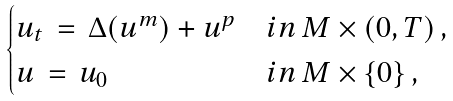Convert formula to latex. <formula><loc_0><loc_0><loc_500><loc_500>\begin{cases} u _ { t } \, = \, \Delta ( u ^ { m } ) + u ^ { p } & i n \, M \times ( 0 , T ) \, , \\ u \, = \, u _ { 0 } & i n \, M \times \{ 0 \} \, , \end{cases}</formula> 